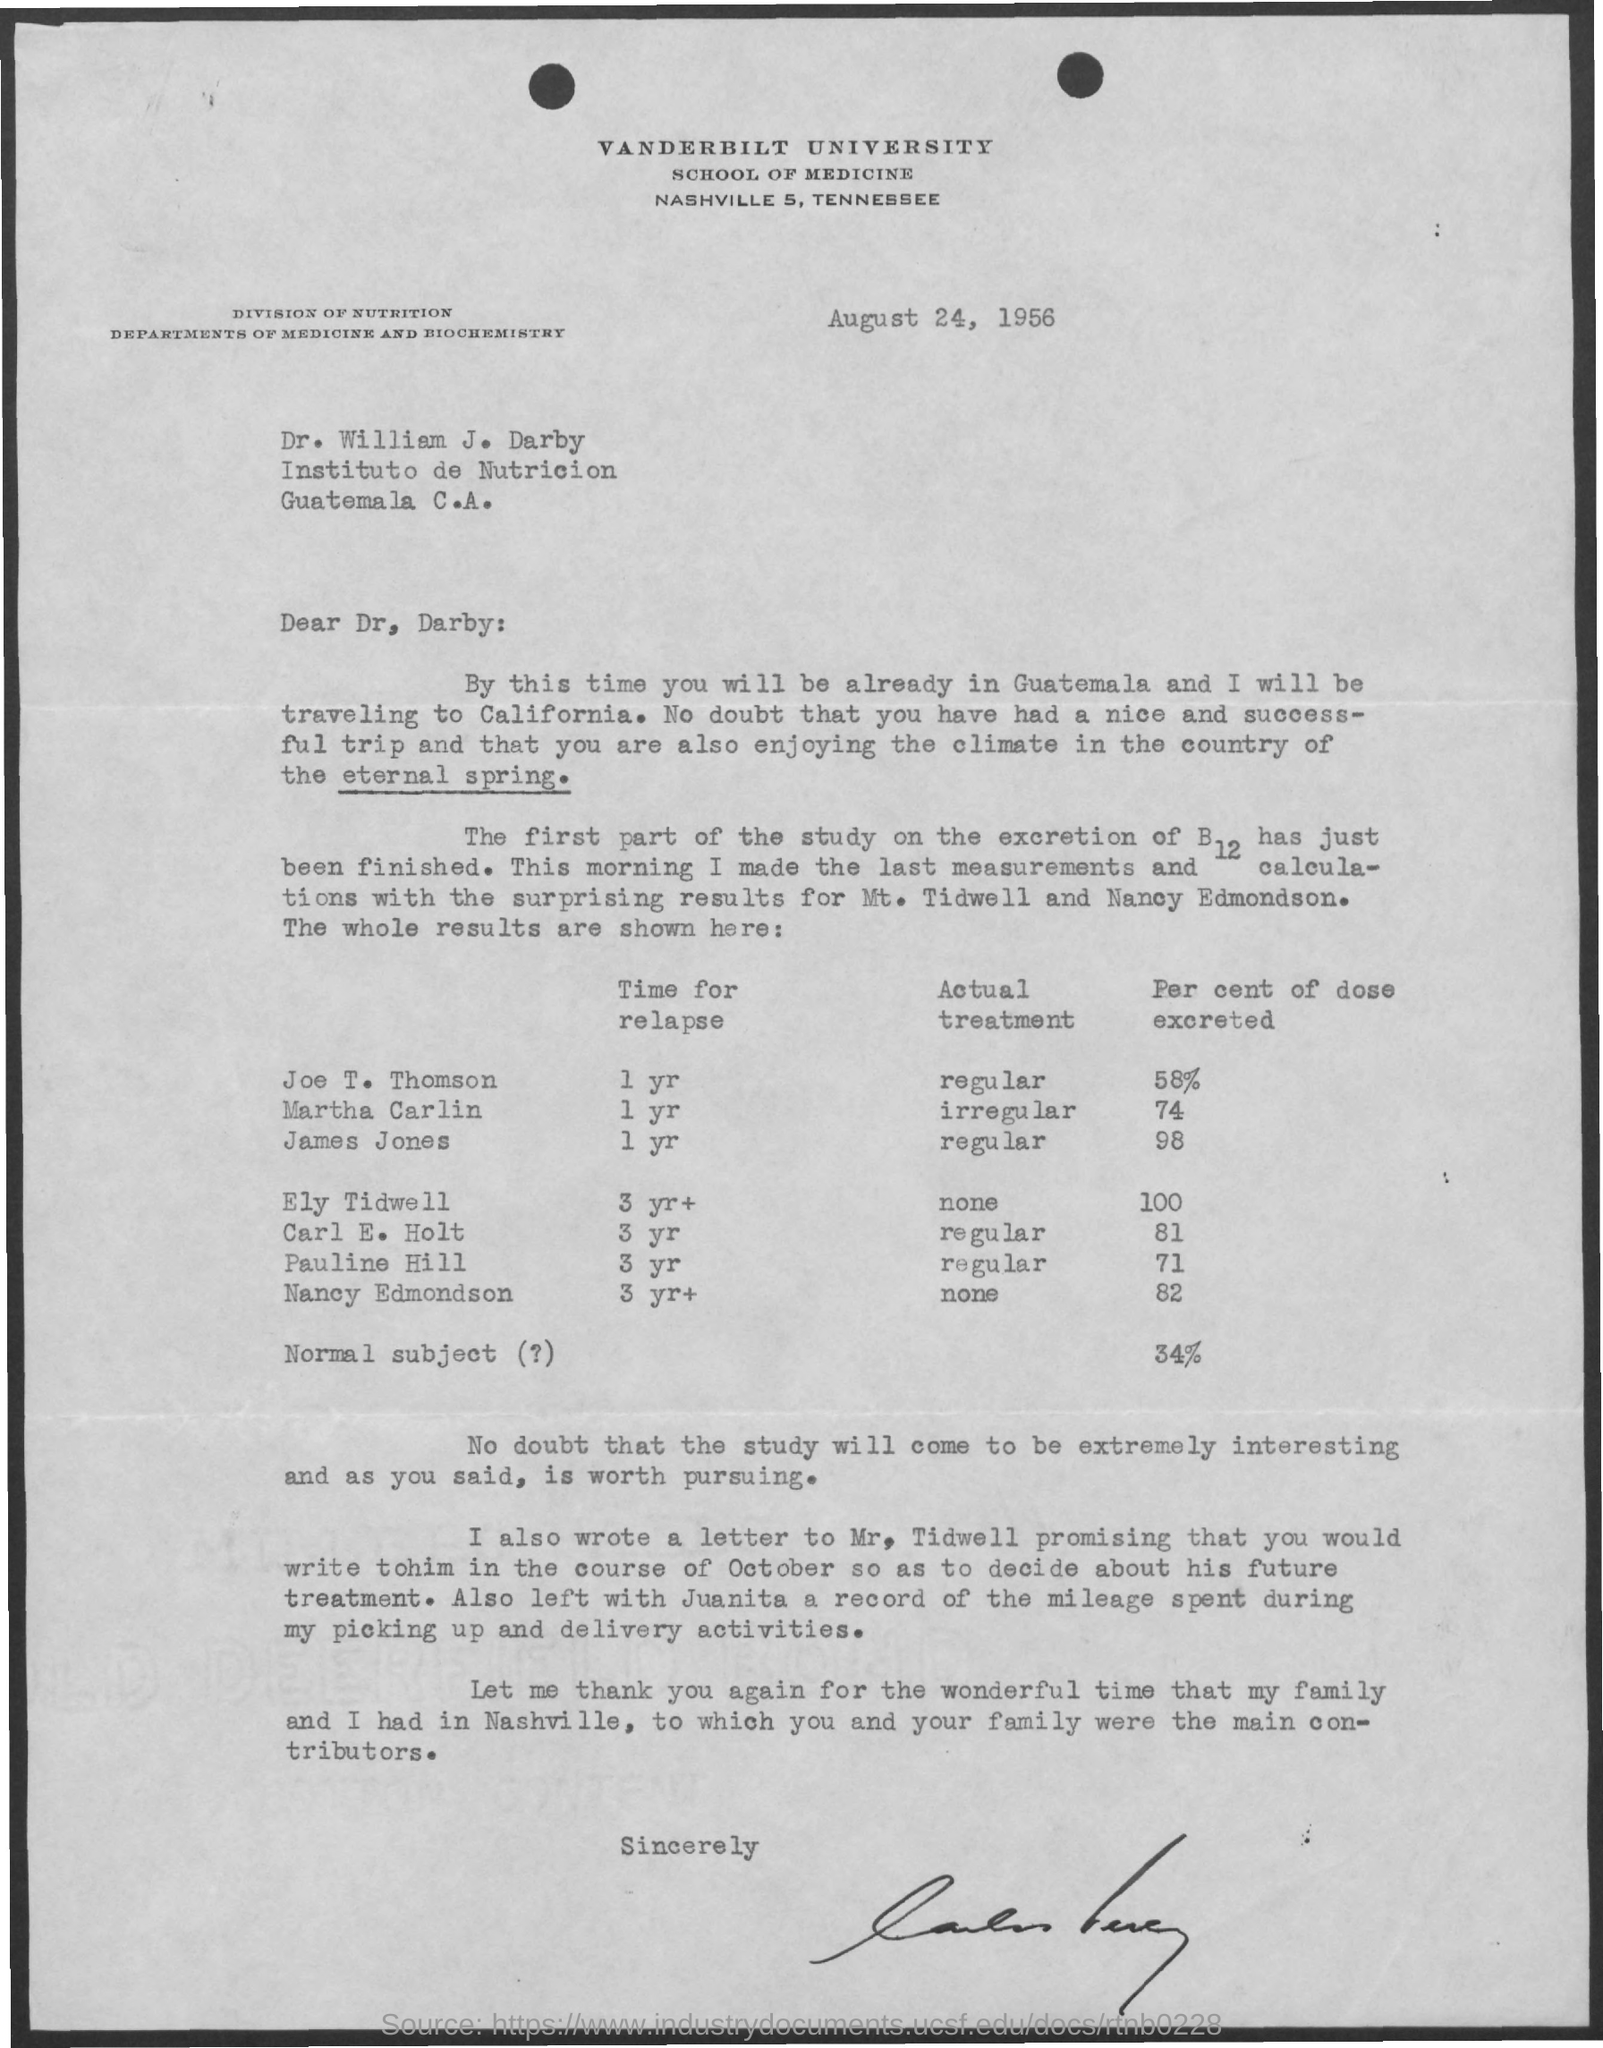Which University is mentioned in the letter head?
Ensure brevity in your answer.  Vanderbilt University. What is the issued date of this letter?
Keep it short and to the point. August 24, 1956. Who is the addressee of this letter?
Your response must be concise. Dr. William J. Darby. What is the time for relapse calculated for Joe T. Thomson?
Your response must be concise. 1 yr. What percent dose of B12 is excreted by Martha Carlin as per the study?
Your answer should be very brief. 74. What percent dose of B12 is excreted by James Jones as per the study?
Your answer should be very brief. 98. 